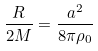<formula> <loc_0><loc_0><loc_500><loc_500>\frac { R } { 2 M } = \frac { a ^ { 2 } } { 8 \pi \rho _ { 0 } }</formula> 